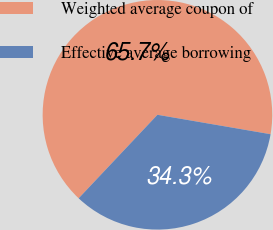Convert chart. <chart><loc_0><loc_0><loc_500><loc_500><pie_chart><fcel>Weighted average coupon of<fcel>Effective average borrowing<nl><fcel>65.67%<fcel>34.33%<nl></chart> 